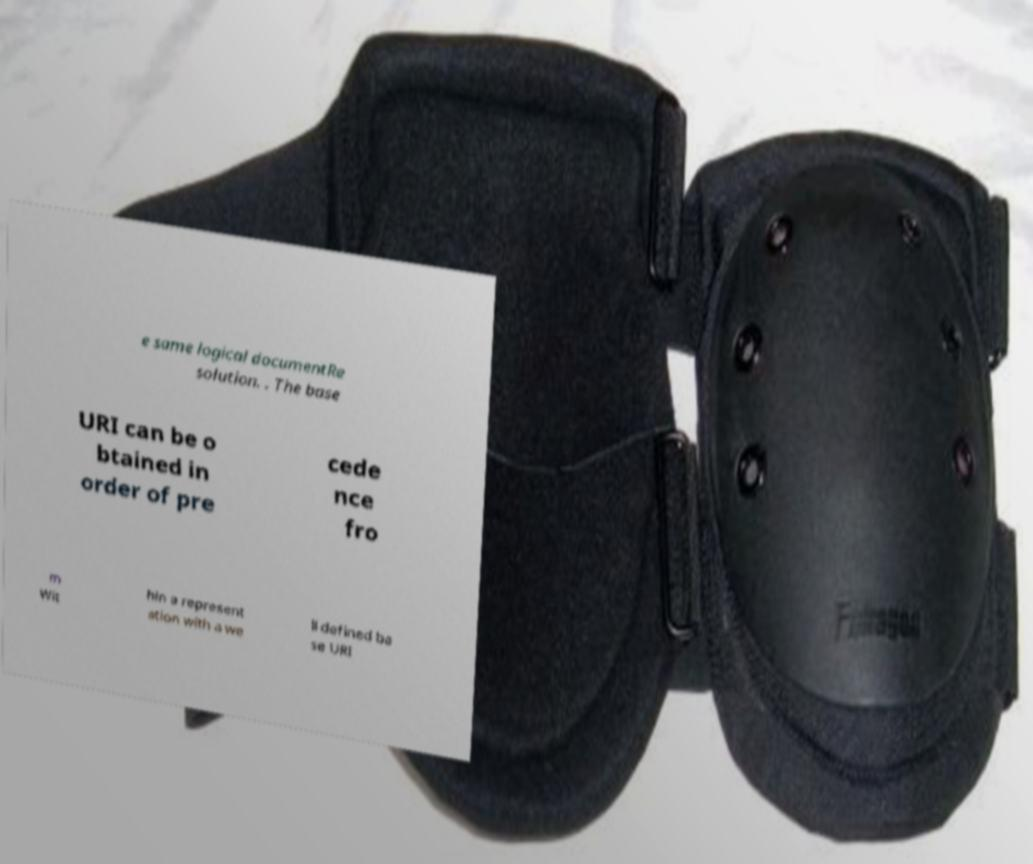I need the written content from this picture converted into text. Can you do that? e same logical documentRe solution. . The base URI can be o btained in order of pre cede nce fro m Wit hin a represent ation with a we ll defined ba se URI 